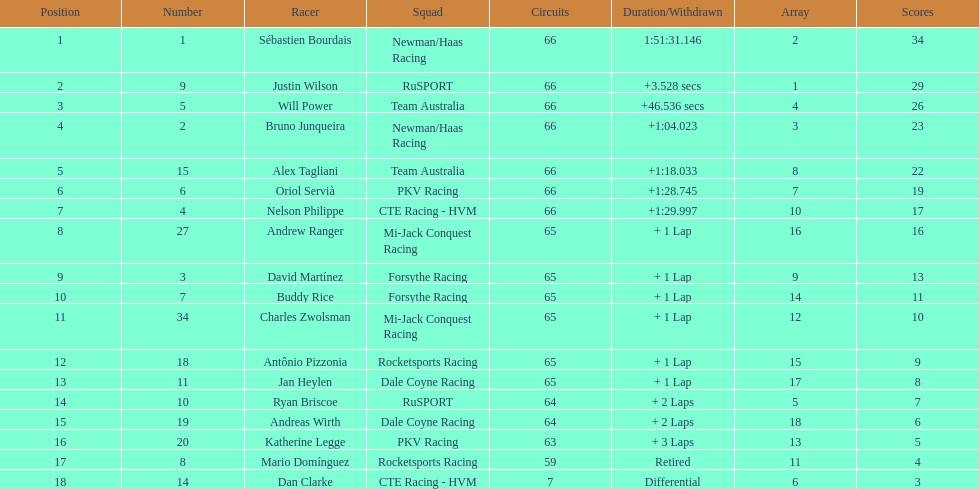At the 2006 gran premio telmex, did oriol servia or katherine legge complete more laps? Oriol Servià. 